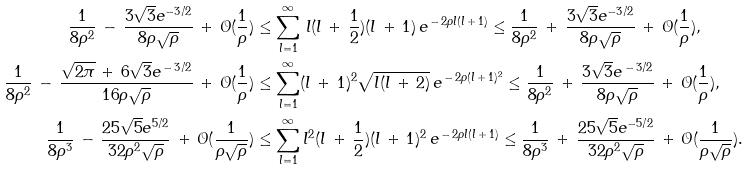Convert formula to latex. <formula><loc_0><loc_0><loc_500><loc_500>\frac { 1 } { 8 \rho ^ { 2 } } \, - \, \frac { 3 \sqrt { 3 } e ^ { - 3 / 2 } } { 8 \rho \sqrt { \rho } } \, + \, \mathcal { O } ( \frac { 1 } { \rho } ) & \leq \sum _ { l = 1 } ^ { \infty } \, l ( l \, + \, \frac { 1 } { 2 } ) ( l \, + \, 1 ) \, e ^ { \, - \, 2 \rho l ( l \, + \, 1 ) } \leq \frac { 1 } { 8 \rho ^ { 2 } } \, + \, \frac { 3 \sqrt { 3 } e ^ { - 3 / 2 } } { 8 \rho \sqrt { \rho } } \, + \, \mathcal { O } ( \frac { 1 } { \rho } ) , \\ \frac { 1 } { 8 \rho ^ { 2 } } \, - \, \frac { \sqrt { 2 \pi } \, + \, 6 \sqrt { 3 } e ^ { \, - \, 3 / 2 } } { 1 6 \rho \sqrt { \rho } } \, + \, \mathcal { O } ( \frac { 1 } { \rho } ) & \leq \sum _ { l = 1 } ^ { \infty } ( l \, + \, 1 ) ^ { 2 } \sqrt { l ( l \, + \, 2 ) } \, e ^ { \, - \, 2 \rho ( l \, + \, 1 ) ^ { 2 } } \leq \frac { 1 } { 8 \rho ^ { 2 } } \, + \, \frac { 3 \sqrt { 3 } e ^ { \, - \, 3 / 2 } } { 8 \rho \sqrt { \rho } } \, + \, \mathcal { O } ( \frac { 1 } { \rho } ) , \\ \frac { 1 } { 8 \rho ^ { 3 } } \, - \, \frac { 2 5 \sqrt { 5 } e ^ { 5 / 2 } } { 3 2 \rho ^ { 2 } \sqrt { \rho } } \, + \, \mathcal { O } ( \frac { 1 } { \rho \sqrt { \rho } } ) & \leq \sum _ { l = 1 } ^ { \infty } l ^ { 2 } ( l \, + \, \frac { 1 } { 2 } ) ( l \, + \, 1 ) ^ { 2 } \, e ^ { \, - \, 2 \rho l ( l \, + \, 1 ) } \leq \frac { 1 } { 8 \rho ^ { 3 } } \, + \, \frac { 2 5 \sqrt { 5 } e ^ { - 5 / 2 } } { 3 2 \rho ^ { 2 } \sqrt { \rho } } \, + \, \mathcal { O } ( \frac { 1 } { \rho \sqrt { \rho } } ) .</formula> 